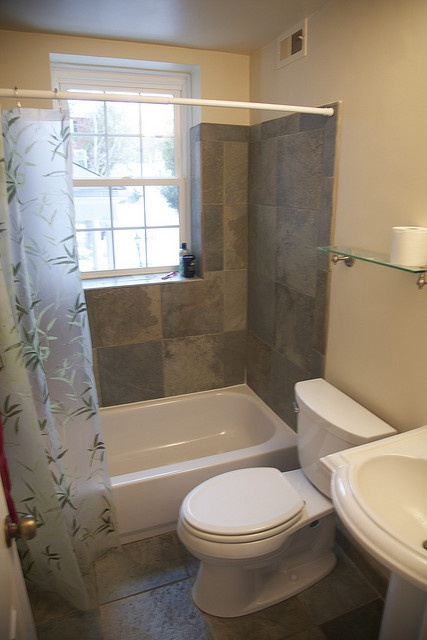Describe the objects in this image and their specific colors. I can see toilet in black, gray, and lightgray tones, sink in tan, beige, and black tones, and bottle in black, gray, and darkgray tones in this image. 